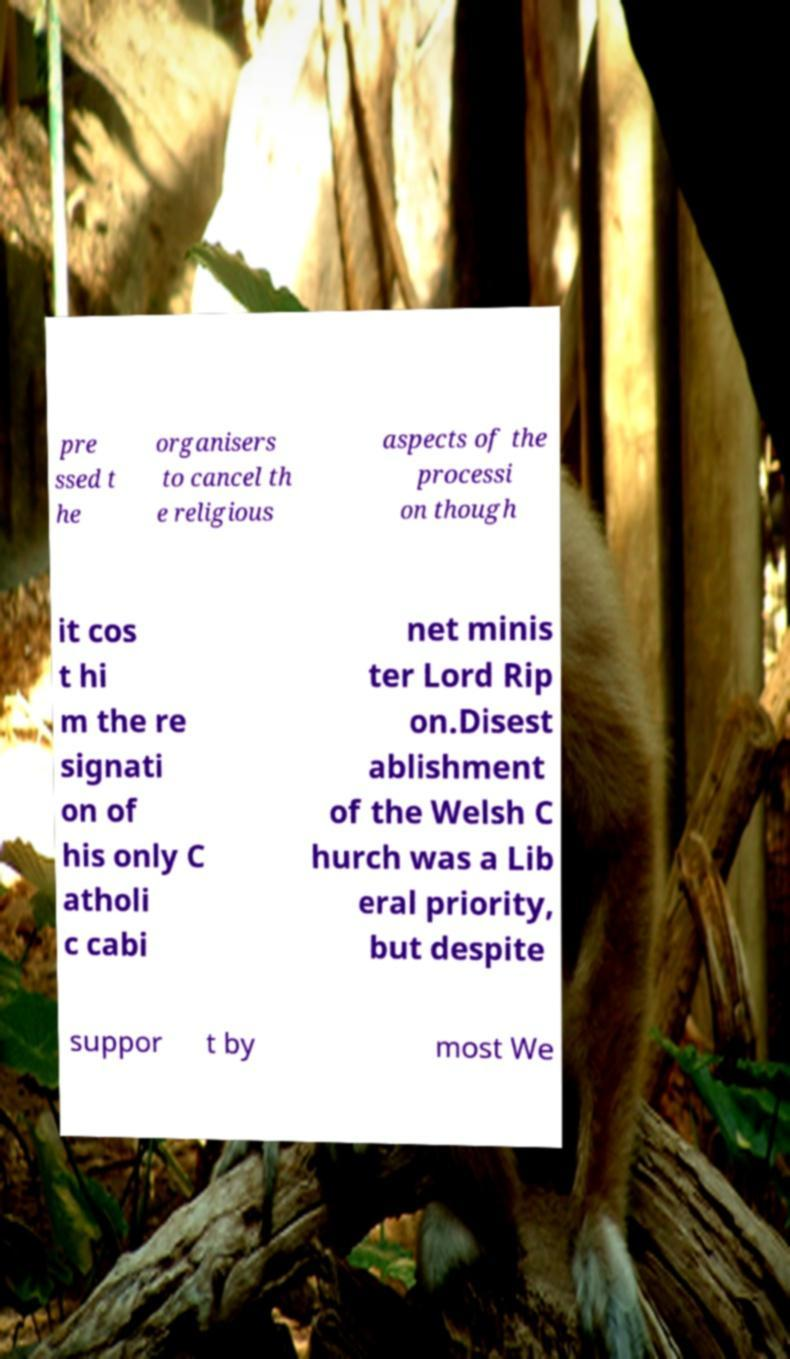Can you read and provide the text displayed in the image?This photo seems to have some interesting text. Can you extract and type it out for me? pre ssed t he organisers to cancel th e religious aspects of the processi on though it cos t hi m the re signati on of his only C atholi c cabi net minis ter Lord Rip on.Disest ablishment of the Welsh C hurch was a Lib eral priority, but despite suppor t by most We 